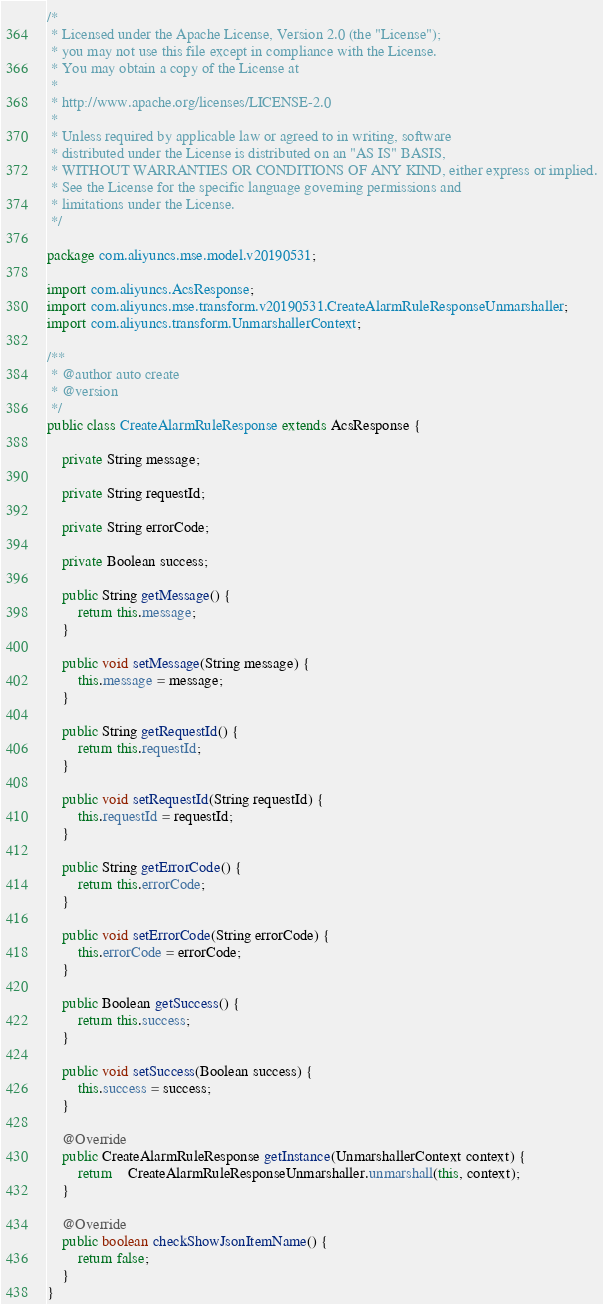<code> <loc_0><loc_0><loc_500><loc_500><_Java_>/*
 * Licensed under the Apache License, Version 2.0 (the "License");
 * you may not use this file except in compliance with the License.
 * You may obtain a copy of the License at
 *
 * http://www.apache.org/licenses/LICENSE-2.0
 *
 * Unless required by applicable law or agreed to in writing, software
 * distributed under the License is distributed on an "AS IS" BASIS,
 * WITHOUT WARRANTIES OR CONDITIONS OF ANY KIND, either express or implied.
 * See the License for the specific language governing permissions and
 * limitations under the License.
 */

package com.aliyuncs.mse.model.v20190531;

import com.aliyuncs.AcsResponse;
import com.aliyuncs.mse.transform.v20190531.CreateAlarmRuleResponseUnmarshaller;
import com.aliyuncs.transform.UnmarshallerContext;

/**
 * @author auto create
 * @version 
 */
public class CreateAlarmRuleResponse extends AcsResponse {

	private String message;

	private String requestId;

	private String errorCode;

	private Boolean success;

	public String getMessage() {
		return this.message;
	}

	public void setMessage(String message) {
		this.message = message;
	}

	public String getRequestId() {
		return this.requestId;
	}

	public void setRequestId(String requestId) {
		this.requestId = requestId;
	}

	public String getErrorCode() {
		return this.errorCode;
	}

	public void setErrorCode(String errorCode) {
		this.errorCode = errorCode;
	}

	public Boolean getSuccess() {
		return this.success;
	}

	public void setSuccess(Boolean success) {
		this.success = success;
	}

	@Override
	public CreateAlarmRuleResponse getInstance(UnmarshallerContext context) {
		return	CreateAlarmRuleResponseUnmarshaller.unmarshall(this, context);
	}

	@Override
	public boolean checkShowJsonItemName() {
		return false;
	}
}
</code> 